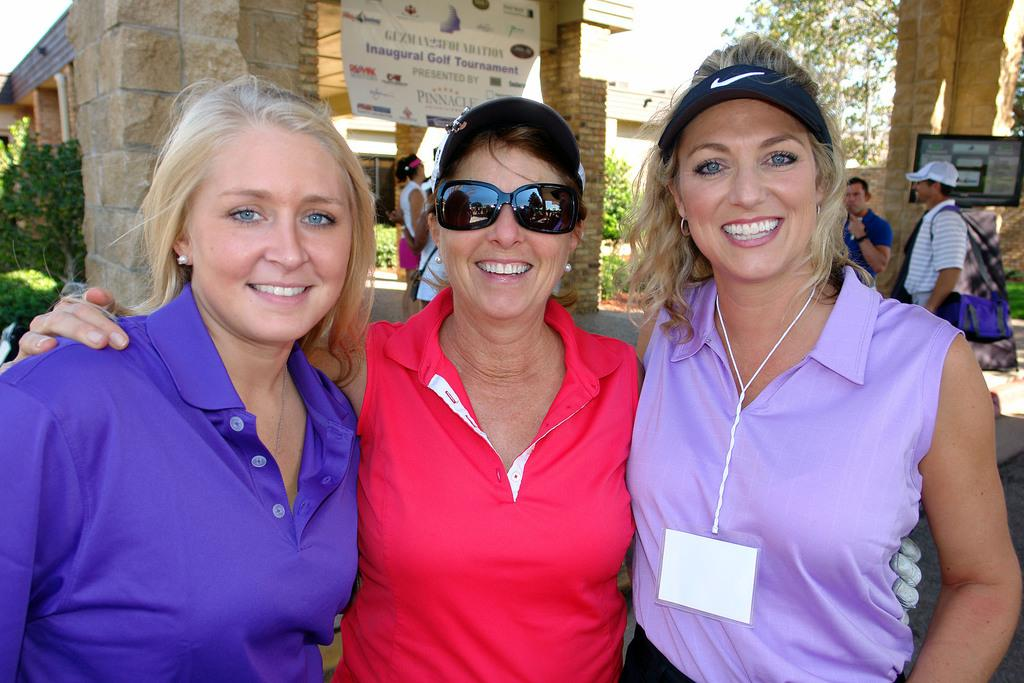How many women are in the image? There are three women in the image. What are the women doing in the image? The women are standing and smiling. Can you describe the background of the image? There are other persons, trees, a banner, a screen, a building, and the sky visible in the background of the image. What discovery did the women make while running in the image? There is no running or discovery depicted in the image; the women are standing and smiling. 